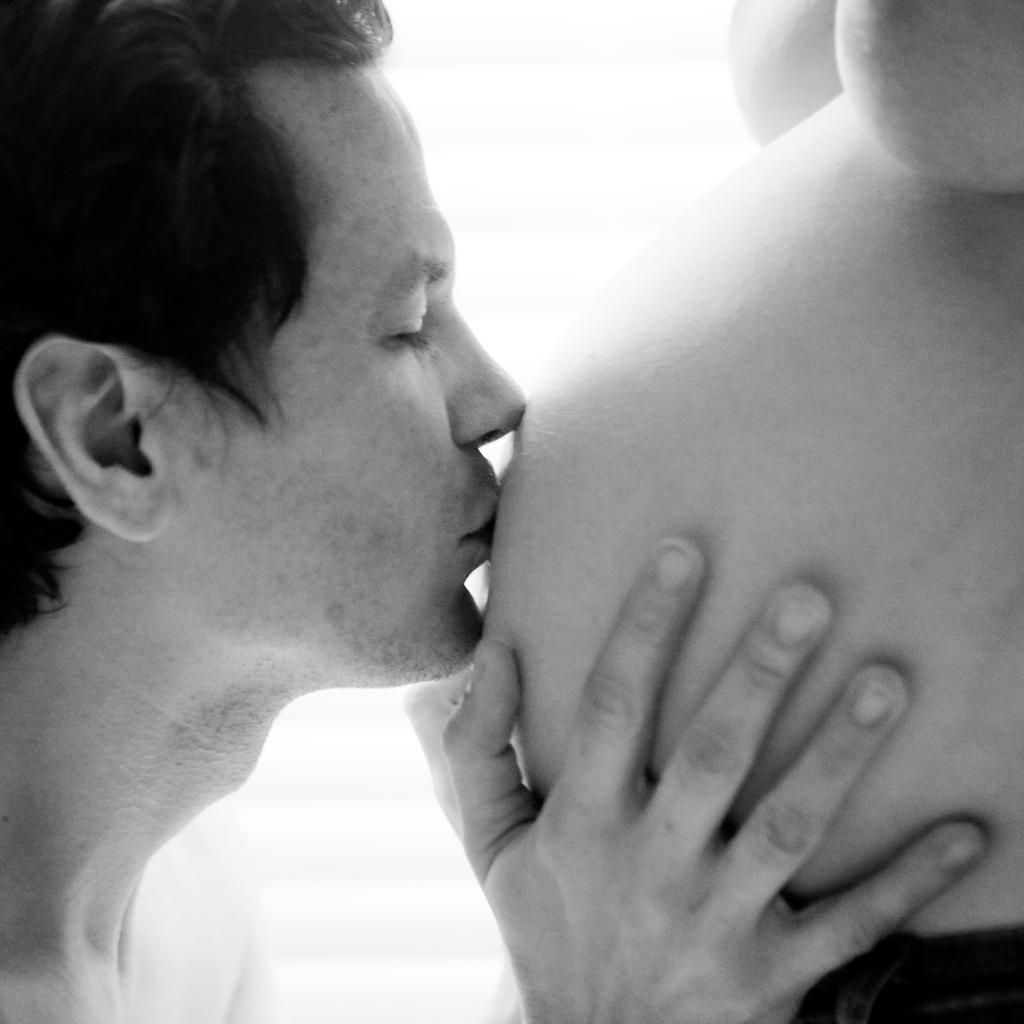How many people are present in the image? There are two persons in the image. What is the man doing in the image? The man is kissing a stomach in the image. What type of songs is the writer composing in the image? There is no writer or songs present in the image; it features two persons, one of whom is kissing a stomach. What is the color of the sky in the image? The provided facts do not mention the sky, so we cannot determine its color from the image. 